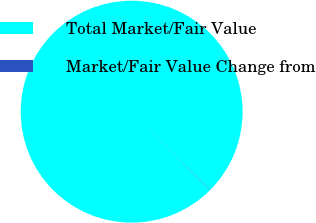<chart> <loc_0><loc_0><loc_500><loc_500><pie_chart><fcel>Total Market/Fair Value<fcel>Market/Fair Value Change from<nl><fcel>99.96%<fcel>0.04%<nl></chart> 